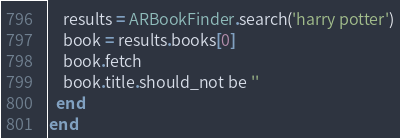<code> <loc_0><loc_0><loc_500><loc_500><_Ruby_>    results = ARBookFinder.search('harry potter')
    book = results.books[0]
    book.fetch
    book.title.should_not be ''
  end
end
</code> 